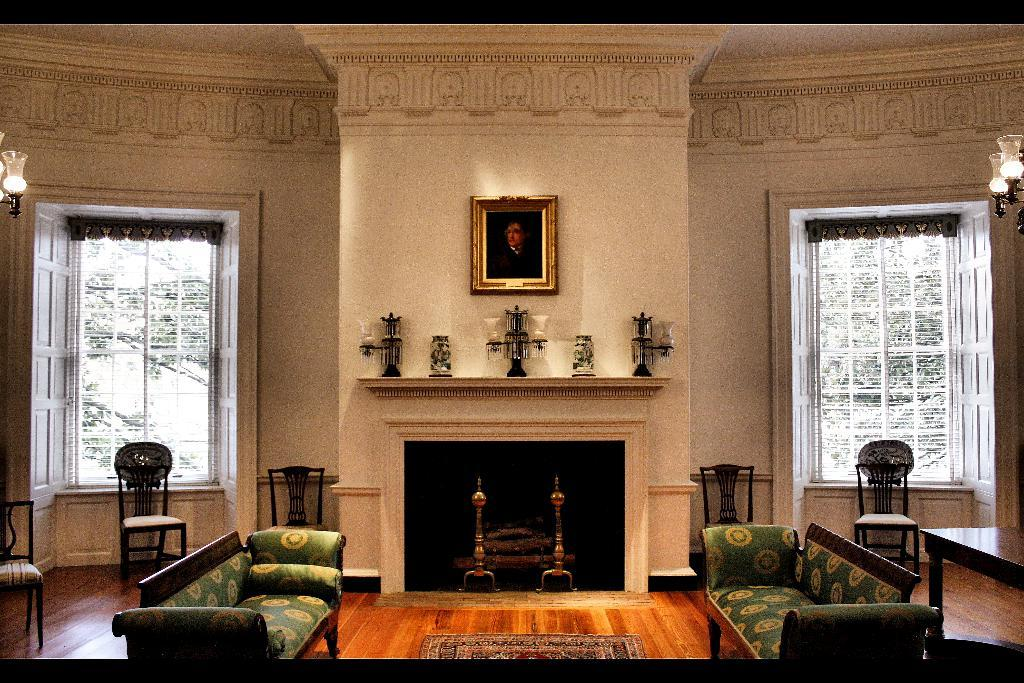What type of furniture is present on either side of the room? There are sofas on either side of the room. What is the condition of the windows in the room? The windows in the room are opened. Can you describe any decorative elements in the room? There is a photo frame fixed to a wall in the room. What process is being carried out in the room during the week? There is no information provided about any process being carried out in the room during the week. What wish is granted by the photo frame in the room? The photo frame in the room is a decorative element and does not grant wishes. 